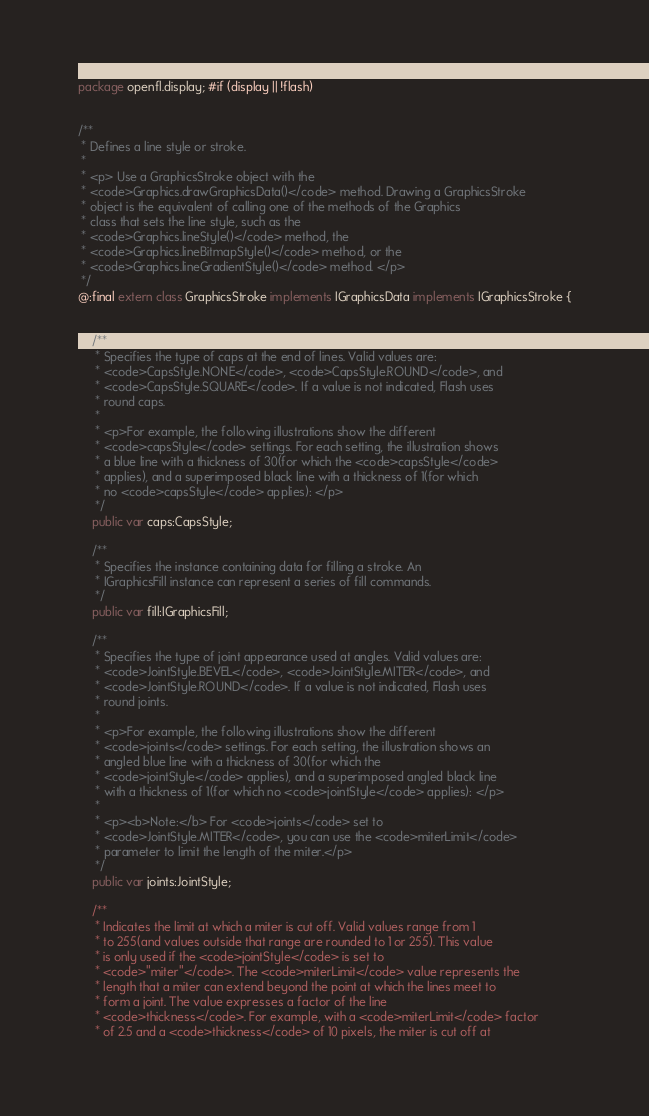Convert code to text. <code><loc_0><loc_0><loc_500><loc_500><_Haxe_>package openfl.display; #if (display || !flash)


/**
 * Defines a line style or stroke.
 *
 * <p> Use a GraphicsStroke object with the
 * <code>Graphics.drawGraphicsData()</code> method. Drawing a GraphicsStroke
 * object is the equivalent of calling one of the methods of the Graphics
 * class that sets the line style, such as the
 * <code>Graphics.lineStyle()</code> method, the
 * <code>Graphics.lineBitmapStyle()</code> method, or the
 * <code>Graphics.lineGradientStyle()</code> method. </p>
 */
@:final extern class GraphicsStroke implements IGraphicsData implements IGraphicsStroke {
	
	
	/**
	 * Specifies the type of caps at the end of lines. Valid values are:
	 * <code>CapsStyle.NONE</code>, <code>CapsStyle.ROUND</code>, and
	 * <code>CapsStyle.SQUARE</code>. If a value is not indicated, Flash uses
	 * round caps.
	 *
	 * <p>For example, the following illustrations show the different
	 * <code>capsStyle</code> settings. For each setting, the illustration shows
	 * a blue line with a thickness of 30(for which the <code>capsStyle</code>
	 * applies), and a superimposed black line with a thickness of 1(for which
	 * no <code>capsStyle</code> applies): </p>
	 */
	public var caps:CapsStyle;
	
	/**
	 * Specifies the instance containing data for filling a stroke. An
	 * IGraphicsFill instance can represent a series of fill commands.
	 */
	public var fill:IGraphicsFill;
	
	/**
	 * Specifies the type of joint appearance used at angles. Valid values are:
	 * <code>JointStyle.BEVEL</code>, <code>JointStyle.MITER</code>, and
	 * <code>JointStyle.ROUND</code>. If a value is not indicated, Flash uses
	 * round joints.
	 *
	 * <p>For example, the following illustrations show the different
	 * <code>joints</code> settings. For each setting, the illustration shows an
	 * angled blue line with a thickness of 30(for which the
	 * <code>jointStyle</code> applies), and a superimposed angled black line
	 * with a thickness of 1(for which no <code>jointStyle</code> applies): </p>
	 *
	 * <p><b>Note:</b> For <code>joints</code> set to
	 * <code>JointStyle.MITER</code>, you can use the <code>miterLimit</code>
	 * parameter to limit the length of the miter.</p>
	 */
	public var joints:JointStyle;
	
	/**
	 * Indicates the limit at which a miter is cut off. Valid values range from 1
	 * to 255(and values outside that range are rounded to 1 or 255). This value
	 * is only used if the <code>jointStyle</code> is set to
	 * <code>"miter"</code>. The <code>miterLimit</code> value represents the
	 * length that a miter can extend beyond the point at which the lines meet to
	 * form a joint. The value expresses a factor of the line
	 * <code>thickness</code>. For example, with a <code>miterLimit</code> factor
	 * of 2.5 and a <code>thickness</code> of 10 pixels, the miter is cut off at</code> 